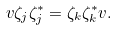<formula> <loc_0><loc_0><loc_500><loc_500>v \zeta _ { j } \zeta _ { j } ^ { * } = \zeta _ { k } \zeta _ { k } ^ { * } v .</formula> 